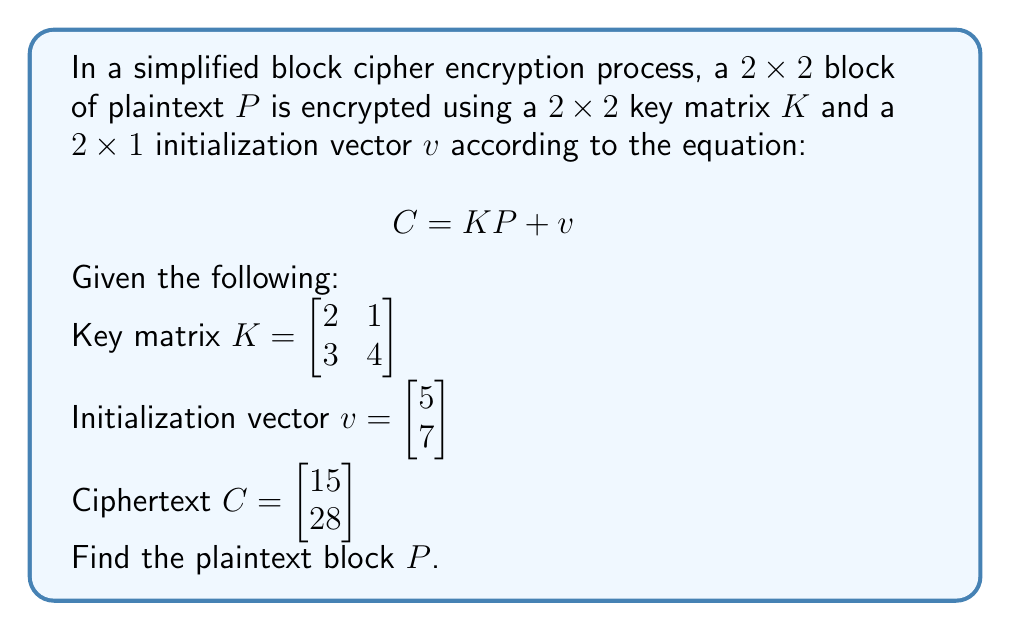Could you help me with this problem? To solve this problem, we need to follow these steps:

1) We start with the encryption equation:
   $$C = KP + v$$

2) To find $P$, we need to isolate it. First, subtract $v$ from both sides:
   $$C - v = KP$$

3) Let's perform this subtraction:
   $$\begin{bmatrix} 15 \\ 28 \end{bmatrix} - \begin{bmatrix} 5 \\ 7 \end{bmatrix} = \begin{bmatrix} 10 \\ 21 \end{bmatrix} = KP$$

4) Now we have:
   $$\begin{bmatrix} 10 \\ 21 \end{bmatrix} = \begin{bmatrix} 2 & 1 \\ 3 & 4 \end{bmatrix}P$$

5) To solve for $P$, we need to multiply both sides by the inverse of $K$:
   $$K^{-1}\begin{bmatrix} 10 \\ 21 \end{bmatrix} = K^{-1}KP = P$$

6) Let's calculate $K^{-1}$:
   $$K^{-1} = \frac{1}{2(4) - 1(3)} \begin{bmatrix} 4 & -1 \\ -3 & 2 \end{bmatrix} = \begin{bmatrix} 8/5 & -1/5 \\ -3/5 & 2/5 \end{bmatrix}$$

7) Now we can solve for $P$:
   $$P = \begin{bmatrix} 8/5 & -1/5 \\ -3/5 & 2/5 \end{bmatrix} \begin{bmatrix} 10 \\ 21 \end{bmatrix}$$

8) Performing the matrix multiplication:
   $$P = \begin{bmatrix} (8/5 * 10) + (-1/5 * 21) \\ (-3/5 * 10) + (2/5 * 21) \end{bmatrix} = \begin{bmatrix} 80/5 - 21/5 \\ -30/5 + 42/5 \end{bmatrix} = \begin{bmatrix} 59/5 \\ 12/5 \end{bmatrix}$$

Therefore, the plaintext block $P$ is $\begin{bmatrix} 59/5 \\ 12/5 \end{bmatrix}$.
Answer: $P = \begin{bmatrix} 59/5 \\ 12/5 \end{bmatrix}$ 